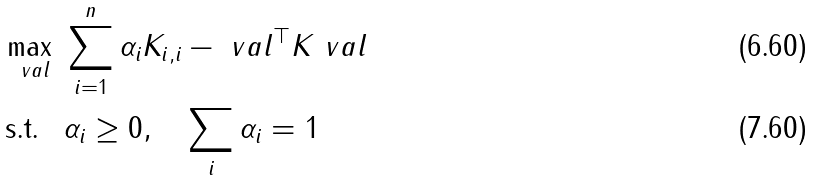<formula> <loc_0><loc_0><loc_500><loc_500>\max _ { \ v a l } \, & \, \sum _ { i = 1 } ^ { n } \alpha _ { i } K _ { i , i } - \ v a l ^ { \top } K \ v a l \\ \text {s.t. } \, & \, \alpha _ { i } \geq 0 , \quad \sum _ { i } \alpha _ { i } = 1</formula> 